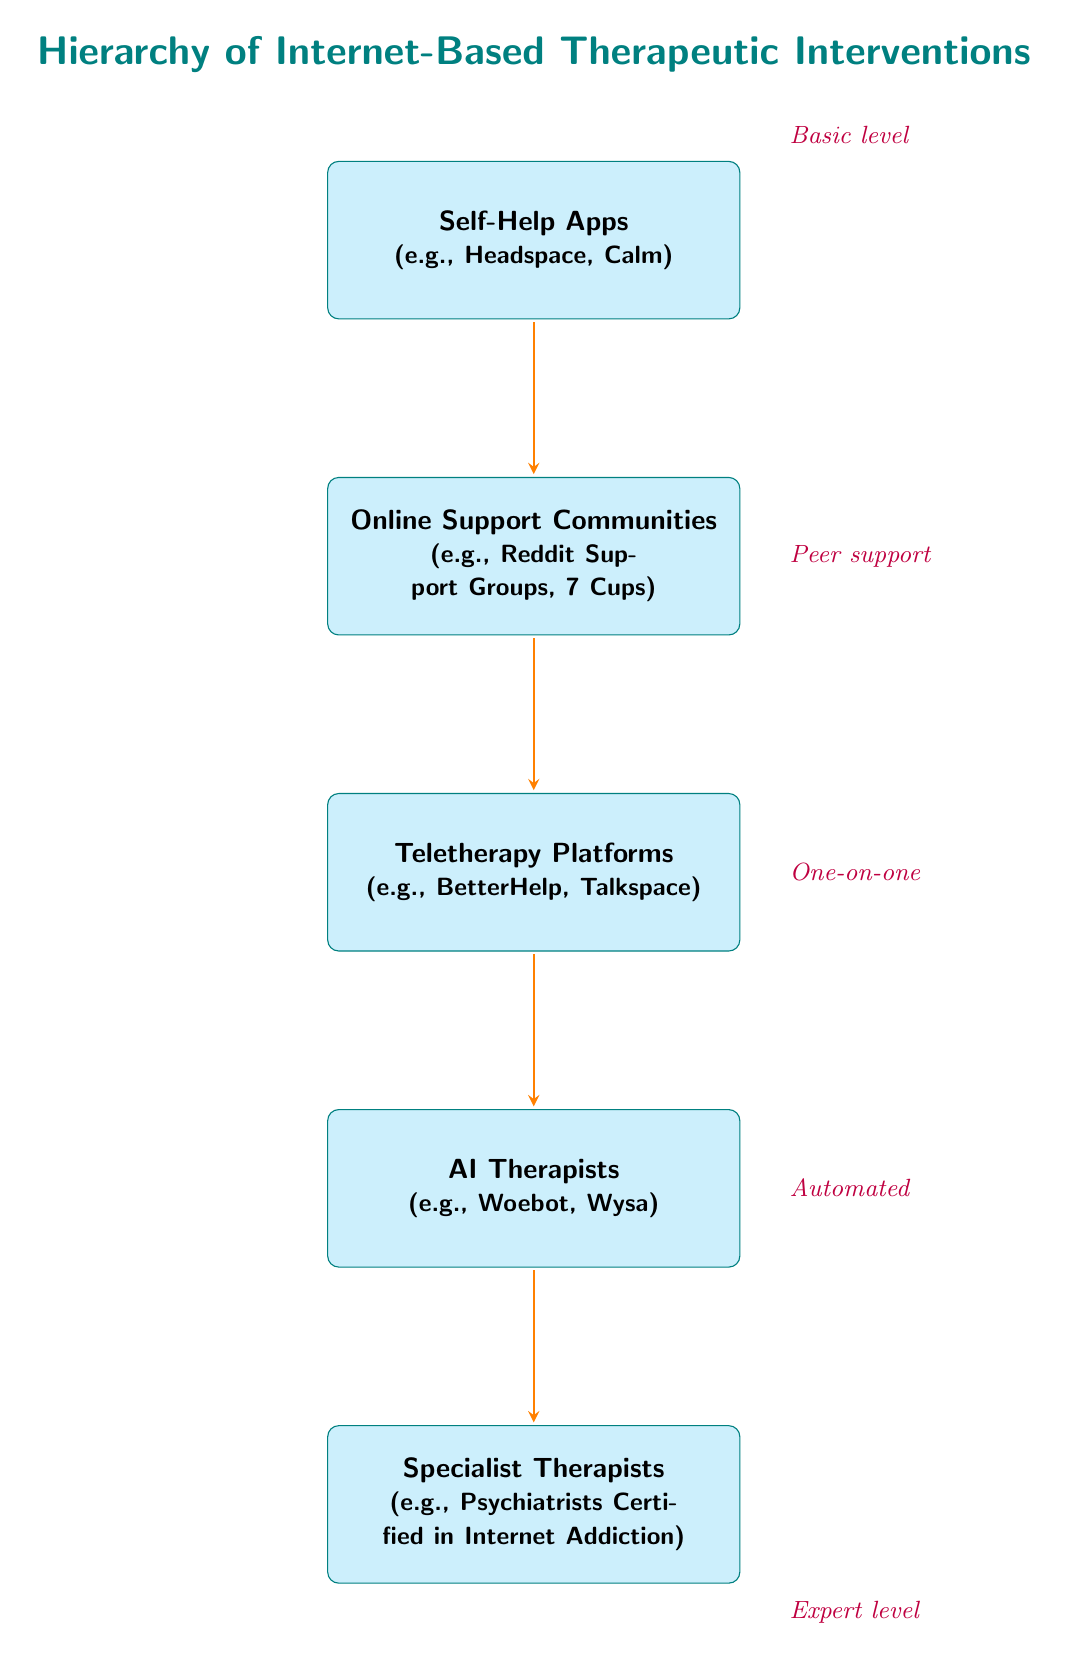What is the top node in the hierarchy? The top node is where the hierarchy begins, which represents the basic level of internet-based therapeutic interventions. According to the diagram, that is "Self-Help Apps."
Answer: Self-Help Apps How many nodes are present in the hierarchy? By counting each distinct element represented within the hierarchy, including the title, there are five main nodes present, excluding any additional information.
Answer: 5 What type of support does the "Online Support Communities" provide? This node indicates a level of interaction among peers, which characterizes it as peer support. The description next to it specifies that it is involving people in similar situations.
Answer: Peer support Which node comes after "Teletherapy Platforms" in the hierarchy? The arrows in the diagram indicate the flow from one node to the next. Following "Teletherapy Platforms," the next node down is "AI Therapists."
Answer: AI Therapists What kind of interventions does the "Specialist Therapists" represent? Looking at the positioning and relationships in the diagram, this node represents the expert level of therapeutic intervention available in the hierarchy. It points to its significant role in providing specialized treatment.
Answer: Expert level What is the relationship between "AI Therapists" and "Specialist Therapists"? In the diagram, the arrow emanating from "AI Therapists" points directly to "Specialist Therapists," indicating a flow or progression in the hierarchy from automated support to expert care.
Answer: Progression What is the content of the first node in the hierarchy? The first node in the hierarchy is the starting point labeled "Self-Help Apps," which illustrates the most accessible form of intervention.
Answer: Self-Help Apps How does "Teletherapy Platforms" differ from "Online Support Communities"? The diagram shows that "Teletherapy Platforms" is positioned below "Online Support Communities" and is characterized as providing one-on-one professional help, unlike the peer support found in "Online Support Communities."
Answer: One-on-one What do the colored labels next to each node signify? The colored labels provide context about the nature and type of support offered at each level of the hierarchy, indicating basic to expert levels of intervention. This helps to understand the progression of intervention complexity.
Answer: Nature of support 